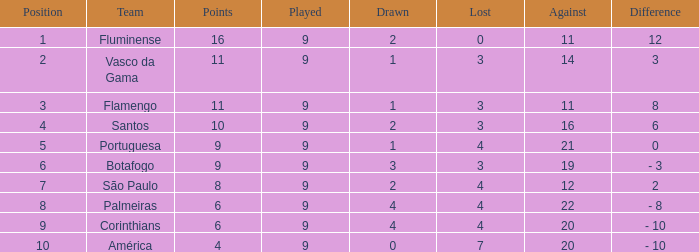Which Points is the highest one that has a Position of 1, and a Lost smaller than 0? None. 